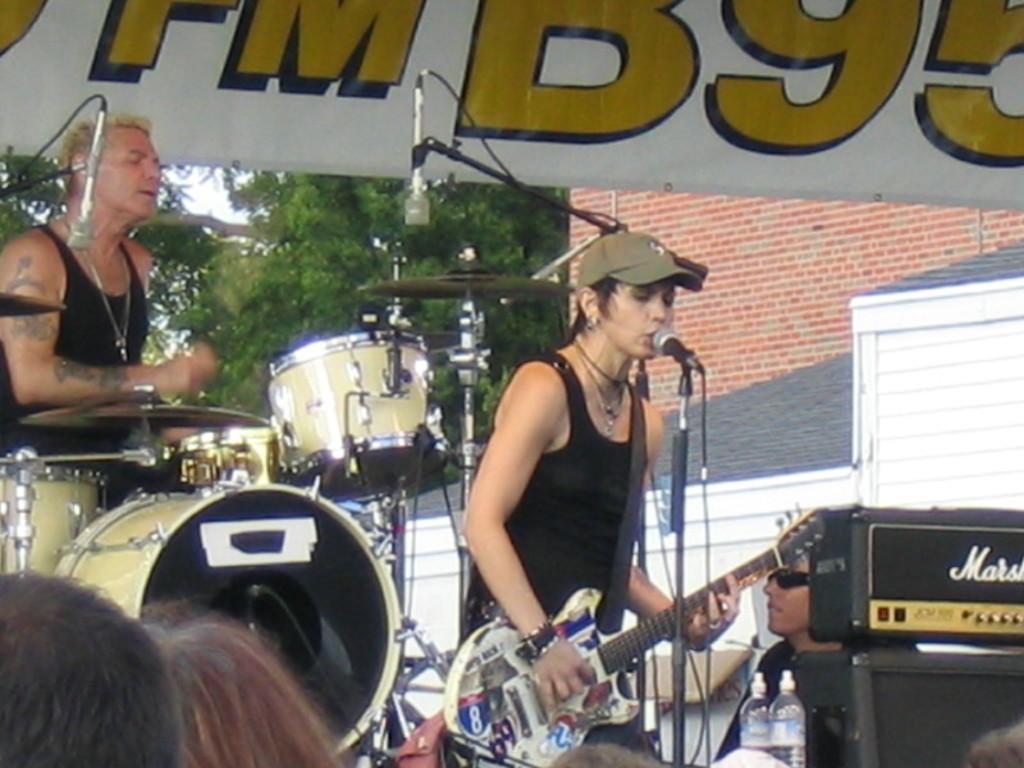In one or two sentences, can you explain what this image depicts? In this picture there are two people standing this person as playing a guitar and singing and this person is playing the drum set 